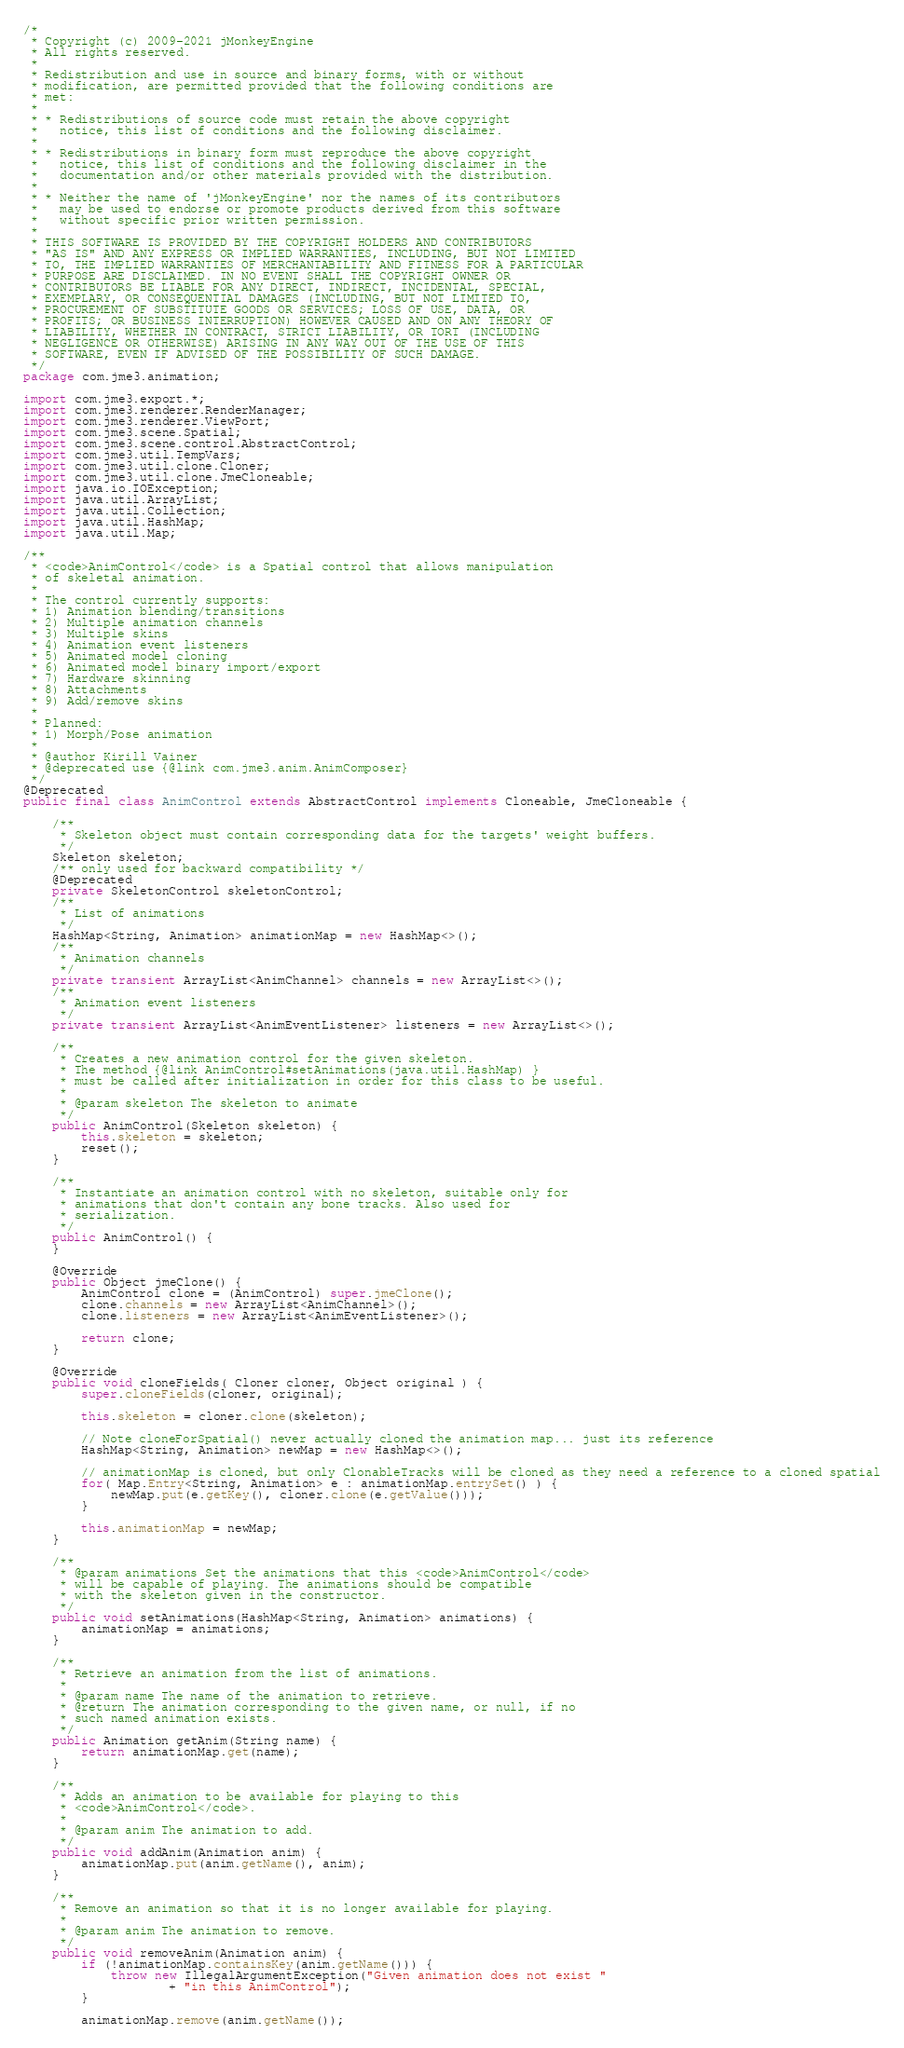Convert code to text. <code><loc_0><loc_0><loc_500><loc_500><_Java_>/*
 * Copyright (c) 2009-2021 jMonkeyEngine
 * All rights reserved.
 *
 * Redistribution and use in source and binary forms, with or without
 * modification, are permitted provided that the following conditions are
 * met:
 *
 * * Redistributions of source code must retain the above copyright
 *   notice, this list of conditions and the following disclaimer.
 *
 * * Redistributions in binary form must reproduce the above copyright
 *   notice, this list of conditions and the following disclaimer in the
 *   documentation and/or other materials provided with the distribution.
 *
 * * Neither the name of 'jMonkeyEngine' nor the names of its contributors
 *   may be used to endorse or promote products derived from this software
 *   without specific prior written permission.
 *
 * THIS SOFTWARE IS PROVIDED BY THE COPYRIGHT HOLDERS AND CONTRIBUTORS
 * "AS IS" AND ANY EXPRESS OR IMPLIED WARRANTIES, INCLUDING, BUT NOT LIMITED
 * TO, THE IMPLIED WARRANTIES OF MERCHANTABILITY AND FITNESS FOR A PARTICULAR
 * PURPOSE ARE DISCLAIMED. IN NO EVENT SHALL THE COPYRIGHT OWNER OR
 * CONTRIBUTORS BE LIABLE FOR ANY DIRECT, INDIRECT, INCIDENTAL, SPECIAL,
 * EXEMPLARY, OR CONSEQUENTIAL DAMAGES (INCLUDING, BUT NOT LIMITED TO,
 * PROCUREMENT OF SUBSTITUTE GOODS OR SERVICES; LOSS OF USE, DATA, OR
 * PROFITS; OR BUSINESS INTERRUPTION) HOWEVER CAUSED AND ON ANY THEORY OF
 * LIABILITY, WHETHER IN CONTRACT, STRICT LIABILITY, OR TORT (INCLUDING
 * NEGLIGENCE OR OTHERWISE) ARISING IN ANY WAY OUT OF THE USE OF THIS
 * SOFTWARE, EVEN IF ADVISED OF THE POSSIBILITY OF SUCH DAMAGE.
 */
package com.jme3.animation;

import com.jme3.export.*;
import com.jme3.renderer.RenderManager;
import com.jme3.renderer.ViewPort;
import com.jme3.scene.Spatial;
import com.jme3.scene.control.AbstractControl;
import com.jme3.util.TempVars;
import com.jme3.util.clone.Cloner;
import com.jme3.util.clone.JmeCloneable;
import java.io.IOException;
import java.util.ArrayList;
import java.util.Collection;
import java.util.HashMap;
import java.util.Map;

/**
 * <code>AnimControl</code> is a Spatial control that allows manipulation
 * of skeletal animation.
 *
 * The control currently supports:
 * 1) Animation blending/transitions
 * 2) Multiple animation channels
 * 3) Multiple skins
 * 4) Animation event listeners
 * 5) Animated model cloning
 * 6) Animated model binary import/export
 * 7) Hardware skinning
 * 8) Attachments
 * 9) Add/remove skins
 *
 * Planned:
 * 1) Morph/Pose animation
 *
 * @author Kirill Vainer
 * @deprecated use {@link com.jme3.anim.AnimComposer}
 */
@Deprecated
public final class AnimControl extends AbstractControl implements Cloneable, JmeCloneable {

    /**
     * Skeleton object must contain corresponding data for the targets' weight buffers.
     */
    Skeleton skeleton;
    /** only used for backward compatibility */
    @Deprecated
    private SkeletonControl skeletonControl;
    /**
     * List of animations
     */
    HashMap<String, Animation> animationMap = new HashMap<>();
    /**
     * Animation channels
     */
    private transient ArrayList<AnimChannel> channels = new ArrayList<>();
    /**
     * Animation event listeners
     */
    private transient ArrayList<AnimEventListener> listeners = new ArrayList<>();

    /**
     * Creates a new animation control for the given skeleton.
     * The method {@link AnimControl#setAnimations(java.util.HashMap) }
     * must be called after initialization in order for this class to be useful.
     *
     * @param skeleton The skeleton to animate
     */
    public AnimControl(Skeleton skeleton) {
        this.skeleton = skeleton;
        reset();
    }

    /**
     * Instantiate an animation control with no skeleton, suitable only for
     * animations that don't contain any bone tracks. Also used for
     * serialization.
     */
    public AnimControl() {
    }

    @Override   
    public Object jmeClone() {
        AnimControl clone = (AnimControl) super.jmeClone();
        clone.channels = new ArrayList<AnimChannel>();
        clone.listeners = new ArrayList<AnimEventListener>();

        return clone;
    }     

    @Override   
    public void cloneFields( Cloner cloner, Object original ) {
        super.cloneFields(cloner, original);
        
        this.skeleton = cloner.clone(skeleton);
 
        // Note cloneForSpatial() never actually cloned the animation map... just its reference       
        HashMap<String, Animation> newMap = new HashMap<>();
         
        // animationMap is cloned, but only ClonableTracks will be cloned as they need a reference to a cloned spatial
        for( Map.Entry<String, Animation> e : animationMap.entrySet() ) {
            newMap.put(e.getKey(), cloner.clone(e.getValue()));
        }
        
        this.animationMap = newMap;
    }
         
    /**
     * @param animations Set the animations that this <code>AnimControl</code>
     * will be capable of playing. The animations should be compatible
     * with the skeleton given in the constructor.
     */
    public void setAnimations(HashMap<String, Animation> animations) {
        animationMap = animations;
    }

    /**
     * Retrieve an animation from the list of animations.
     *
     * @param name The name of the animation to retrieve.
     * @return The animation corresponding to the given name, or null, if no
     * such named animation exists.
     */
    public Animation getAnim(String name) {
        return animationMap.get(name);
    }

    /**
     * Adds an animation to be available for playing to this
     * <code>AnimControl</code>.
     *
     * @param anim The animation to add.
     */
    public void addAnim(Animation anim) {
        animationMap.put(anim.getName(), anim);
    }

    /**
     * Remove an animation so that it is no longer available for playing.
     *
     * @param anim The animation to remove.
     */
    public void removeAnim(Animation anim) {
        if (!animationMap.containsKey(anim.getName())) {
            throw new IllegalArgumentException("Given animation does not exist "
                    + "in this AnimControl");
        }

        animationMap.remove(anim.getName());</code> 